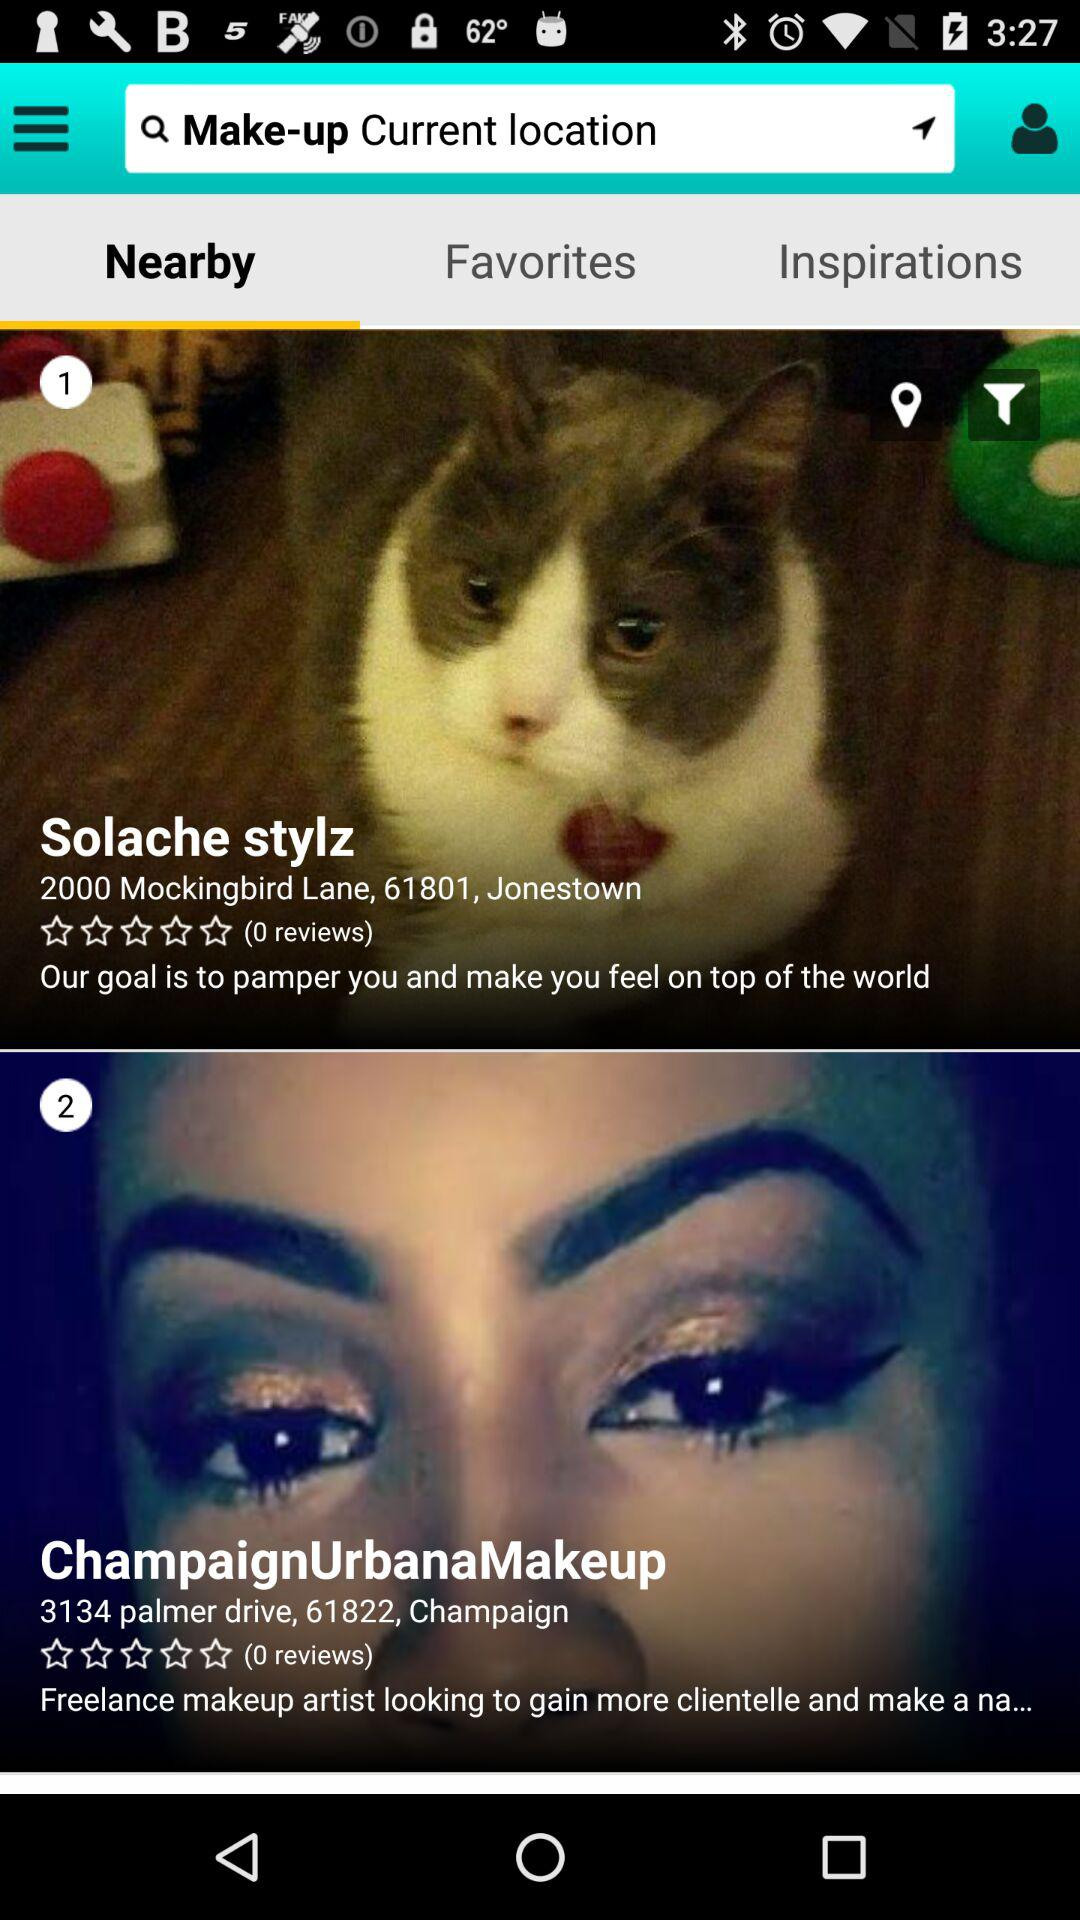Where is Solache stylz located? It is located at 2000 Mockingbird Lane, 61801, Jonestown. 